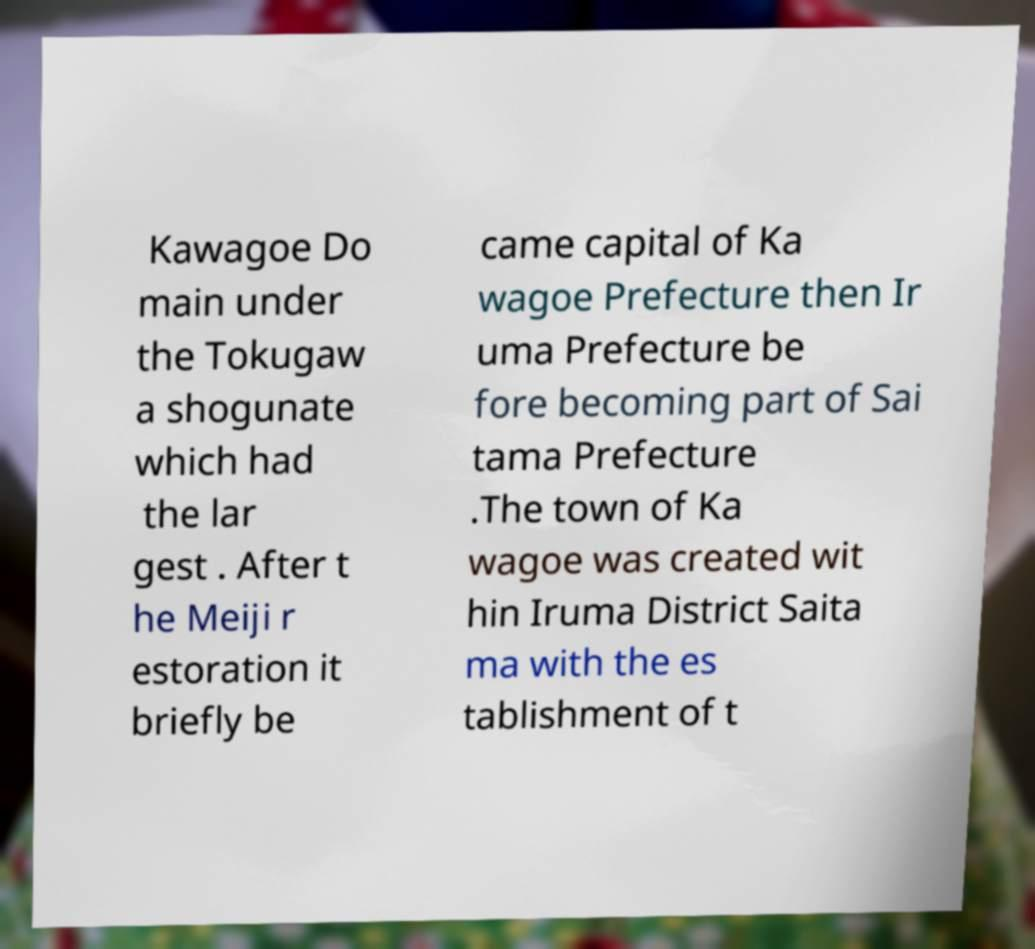Please identify and transcribe the text found in this image. Kawagoe Do main under the Tokugaw a shogunate which had the lar gest . After t he Meiji r estoration it briefly be came capital of Ka wagoe Prefecture then Ir uma Prefecture be fore becoming part of Sai tama Prefecture .The town of Ka wagoe was created wit hin Iruma District Saita ma with the es tablishment of t 